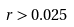Convert formula to latex. <formula><loc_0><loc_0><loc_500><loc_500>r > 0 . 0 2 5</formula> 